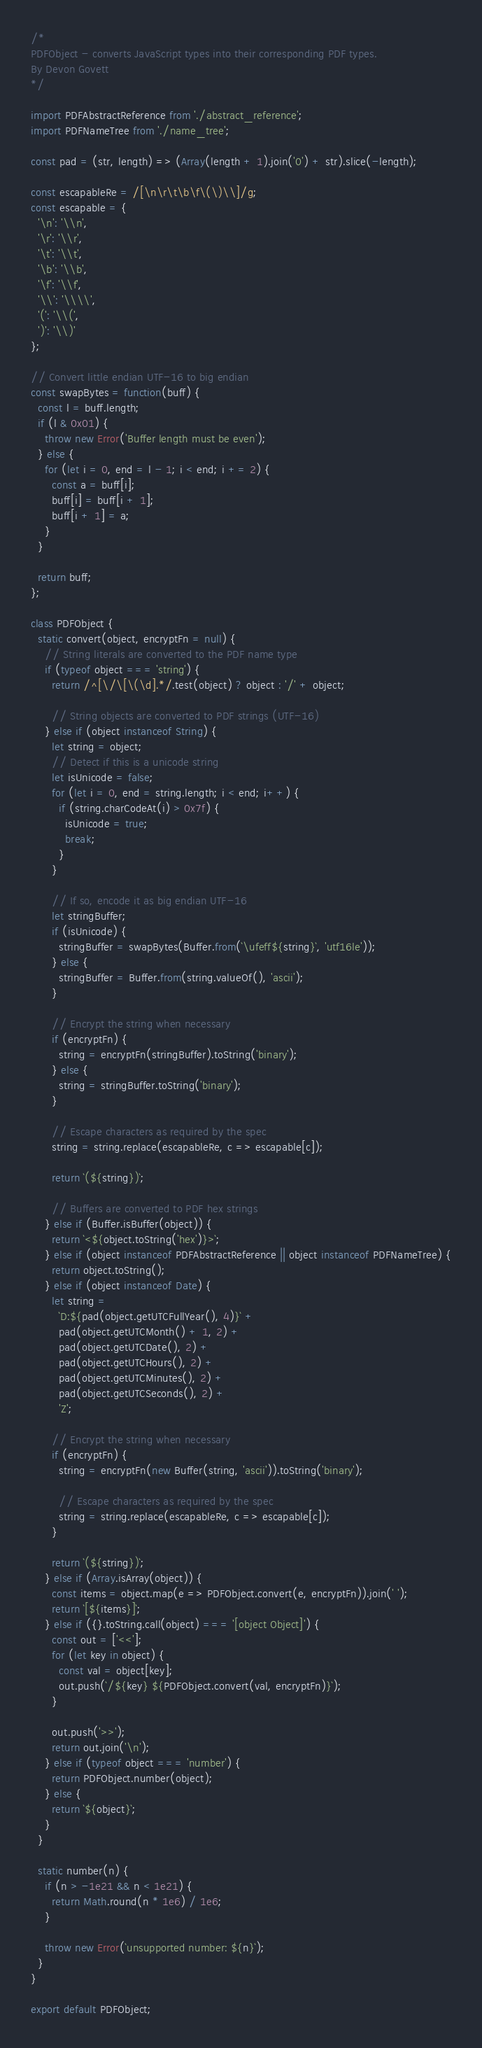Convert code to text. <code><loc_0><loc_0><loc_500><loc_500><_JavaScript_>/*
PDFObject - converts JavaScript types into their corresponding PDF types.
By Devon Govett
*/

import PDFAbstractReference from './abstract_reference';
import PDFNameTree from './name_tree';

const pad = (str, length) => (Array(length + 1).join('0') + str).slice(-length);

const escapableRe = /[\n\r\t\b\f\(\)\\]/g;
const escapable = {
  '\n': '\\n',
  '\r': '\\r',
  '\t': '\\t',
  '\b': '\\b',
  '\f': '\\f',
  '\\': '\\\\',
  '(': '\\(',
  ')': '\\)'
};

// Convert little endian UTF-16 to big endian
const swapBytes = function(buff) {
  const l = buff.length;
  if (l & 0x01) {
    throw new Error('Buffer length must be even');
  } else {
    for (let i = 0, end = l - 1; i < end; i += 2) {
      const a = buff[i];
      buff[i] = buff[i + 1];
      buff[i + 1] = a;
    }
  }

  return buff;
};

class PDFObject {
  static convert(object, encryptFn = null) {
    // String literals are converted to the PDF name type
    if (typeof object === 'string') {
      return /^[\/\[\(\d].*/.test(object) ? object : '/' + object;

      // String objects are converted to PDF strings (UTF-16)
    } else if (object instanceof String) {
      let string = object;
      // Detect if this is a unicode string
      let isUnicode = false;
      for (let i = 0, end = string.length; i < end; i++) {
        if (string.charCodeAt(i) > 0x7f) {
          isUnicode = true;
          break;
        }
      }

      // If so, encode it as big endian UTF-16
      let stringBuffer;
      if (isUnicode) {
        stringBuffer = swapBytes(Buffer.from(`\ufeff${string}`, 'utf16le'));
      } else {
        stringBuffer = Buffer.from(string.valueOf(), 'ascii');
      }

      // Encrypt the string when necessary
      if (encryptFn) {
        string = encryptFn(stringBuffer).toString('binary');
      } else {
        string = stringBuffer.toString('binary');
      }

      // Escape characters as required by the spec
      string = string.replace(escapableRe, c => escapable[c]);

      return `(${string})`;

      // Buffers are converted to PDF hex strings
    } else if (Buffer.isBuffer(object)) {
      return `<${object.toString('hex')}>`;
    } else if (object instanceof PDFAbstractReference || object instanceof PDFNameTree) {
      return object.toString();
    } else if (object instanceof Date) {
      let string =
        `D:${pad(object.getUTCFullYear(), 4)}` +
        pad(object.getUTCMonth() + 1, 2) +
        pad(object.getUTCDate(), 2) +
        pad(object.getUTCHours(), 2) +
        pad(object.getUTCMinutes(), 2) +
        pad(object.getUTCSeconds(), 2) +
        'Z';

      // Encrypt the string when necessary
      if (encryptFn) {
        string = encryptFn(new Buffer(string, 'ascii')).toString('binary');

        // Escape characters as required by the spec
        string = string.replace(escapableRe, c => escapable[c]);
      }

      return `(${string})`;
    } else if (Array.isArray(object)) {
      const items = object.map(e => PDFObject.convert(e, encryptFn)).join(' ');
      return `[${items}]`;
    } else if ({}.toString.call(object) === '[object Object]') {
      const out = ['<<'];
      for (let key in object) {
        const val = object[key];
        out.push(`/${key} ${PDFObject.convert(val, encryptFn)}`);
      }

      out.push('>>');
      return out.join('\n');
    } else if (typeof object === 'number') {
      return PDFObject.number(object);
    } else {
      return `${object}`;
    }
  }

  static number(n) {
    if (n > -1e21 && n < 1e21) {
      return Math.round(n * 1e6) / 1e6;
    }

    throw new Error(`unsupported number: ${n}`);
  }
}

export default PDFObject;
</code> 